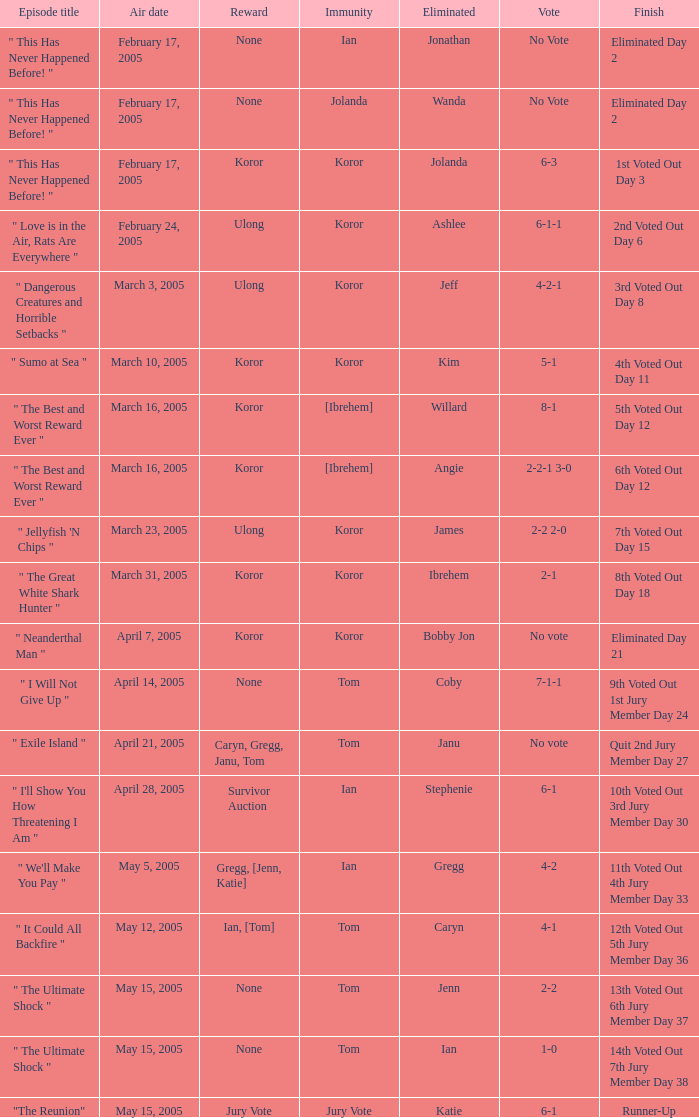What is the name of the episode in which Jenn is eliminated? " The Ultimate Shock ". 